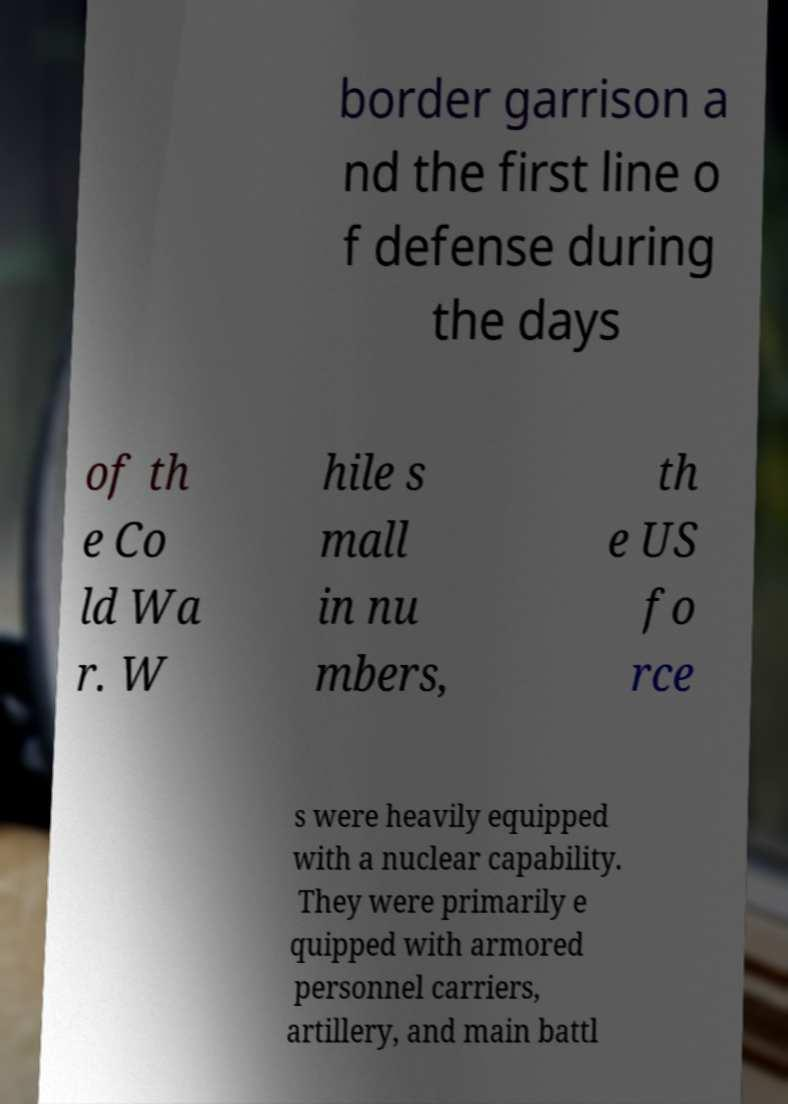Can you read and provide the text displayed in the image?This photo seems to have some interesting text. Can you extract and type it out for me? border garrison a nd the first line o f defense during the days of th e Co ld Wa r. W hile s mall in nu mbers, th e US fo rce s were heavily equipped with a nuclear capability. They were primarily e quipped with armored personnel carriers, artillery, and main battl 